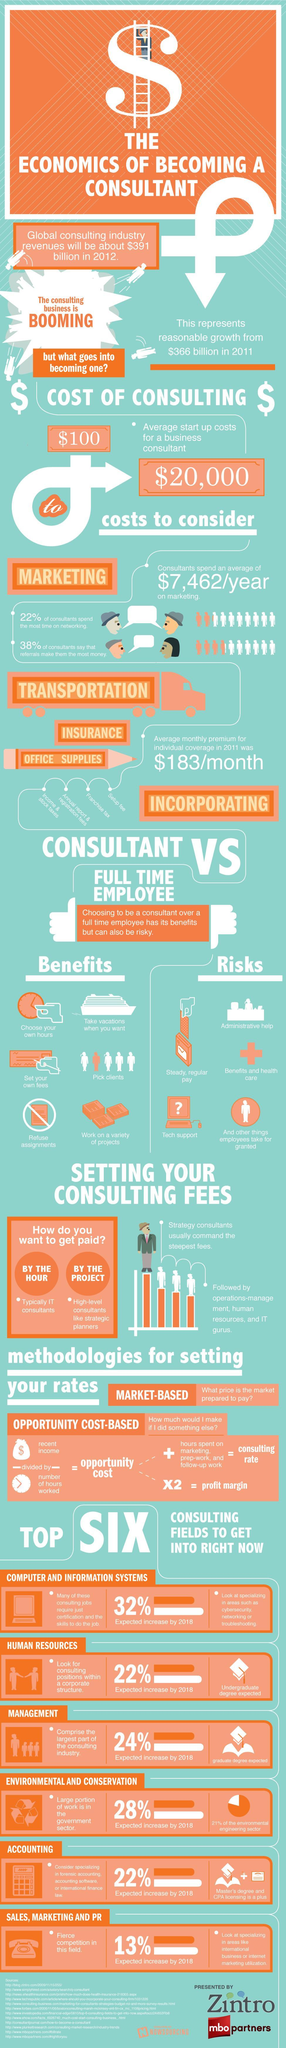What is the annual cost of marketing spent by consultants?
Answer the question with a short phrase. $7,462 How many sources are listed at the bottom? 12 What is the relation between opportunity cost and profit margin? opportunity cost X2 = profit margin By what amount has revenue from Global consulting industry increased from 2011 to 2012? $25 billion 